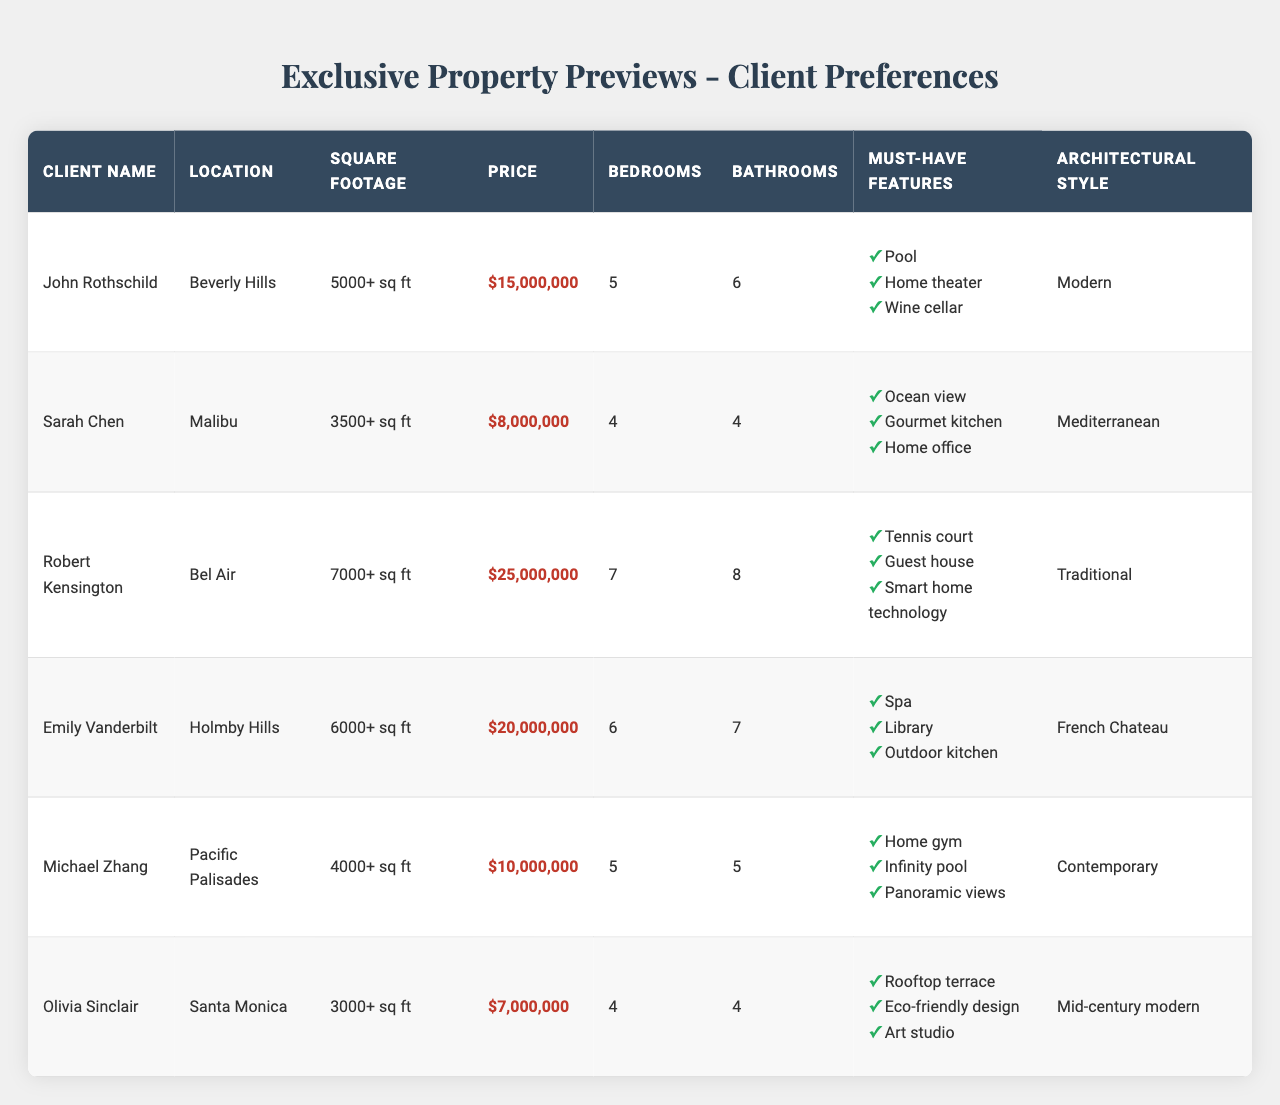What is the maximum price for properties desired by Robert Kensington? Looking at Robert Kensington's entry in the table, the maximum price listed is $25,000,000.
Answer: $25,000,000 Which client has the most bedrooms requirements? In the table, Robert Kensington requires 7 bedrooms, which is the highest number listed compared to other clients.
Answer: Robert Kensington How many clients prefer a beautiful architectural style that includes either Modern or Mediterranean? John Rothschild prefers Modern and Sarah Chen prefers Mediterranean, which sums up to 2 clients fitting the criteria.
Answer: 2 Is there a client who wants a pool as a must-have feature? Yes, John Rothschild specifically lists a pool as one of his must-have features.
Answer: Yes What is the total minimum square footage requirement for all clients combined? Summing up the minimum square footages: 5000 + 3500 + 7000 + 6000 + 4000 + 3000 = 28500.
Answer: 28500 sq ft Which client prioritizes outdoor amenities such as a rooftop terrace? Olivia Sinclair specifies a rooftop terrace as a must-have feature in her requirements.
Answer: Olivia Sinclair How many bathrooms does Emily Vanderbilt require in her future property? Referring to Emily Vanderbilt's information, she needs 7 bathrooms according to the table.
Answer: 7 What is the average maximum price among all clients? Calculating the maximum prices: $15,000,000 + $8,000,000 + $25,000,000 + $20,000,000 + $10,000,000 + $7,000,000 = $85,000,000 and dividing by 6 gives an average of $14,166,667.
Answer: $14,166,667 Do any clients have a requirement for a guest house? Yes, Robert Kensington lists a guest house among his must-have features.
Answer: Yes Which client prefers a contemporary architectural style? Michael Zhang indicates his preference for a contemporary architectural style in the table.
Answer: Michael Zhang 